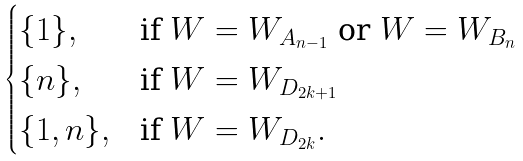<formula> <loc_0><loc_0><loc_500><loc_500>\begin{cases} \{ 1 \} , & \text {if } W = W _ { A _ { n - 1 } } \text { or } W = W _ { B _ { n } } \\ \{ n \} , & \text {if } W = W _ { D _ { 2 k + 1 } } \\ \{ 1 , n \} , & \text {if } W = W _ { D _ { 2 k } } . \end{cases}</formula> 